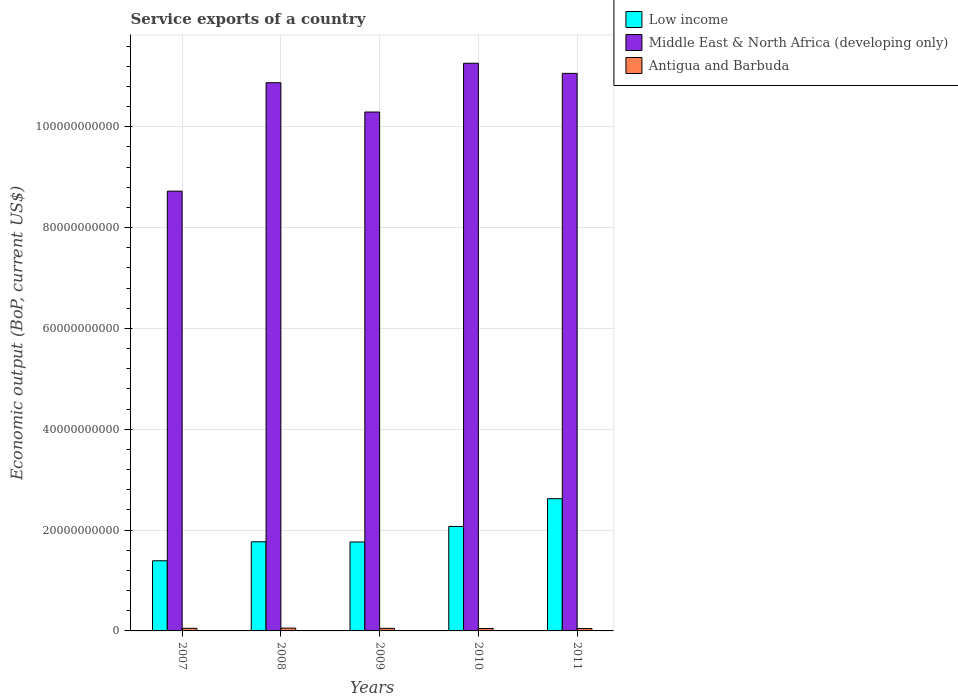How many different coloured bars are there?
Offer a terse response. 3. Are the number of bars on each tick of the X-axis equal?
Your answer should be compact. Yes. How many bars are there on the 1st tick from the left?
Offer a terse response. 3. How many bars are there on the 4th tick from the right?
Keep it short and to the point. 3. What is the label of the 4th group of bars from the left?
Provide a short and direct response. 2010. What is the service exports in Antigua and Barbuda in 2009?
Ensure brevity in your answer.  5.11e+08. Across all years, what is the maximum service exports in Low income?
Keep it short and to the point. 2.62e+1. Across all years, what is the minimum service exports in Middle East & North Africa (developing only)?
Your answer should be compact. 8.72e+1. What is the total service exports in Middle East & North Africa (developing only) in the graph?
Offer a terse response. 5.22e+11. What is the difference between the service exports in Middle East & North Africa (developing only) in 2007 and that in 2010?
Your answer should be very brief. -2.54e+1. What is the difference between the service exports in Middle East & North Africa (developing only) in 2008 and the service exports in Antigua and Barbuda in 2009?
Keep it short and to the point. 1.08e+11. What is the average service exports in Antigua and Barbuda per year?
Provide a succinct answer. 5.11e+08. In the year 2007, what is the difference between the service exports in Middle East & North Africa (developing only) and service exports in Low income?
Offer a terse response. 7.33e+1. What is the ratio of the service exports in Low income in 2007 to that in 2009?
Your answer should be compact. 0.79. Is the difference between the service exports in Middle East & North Africa (developing only) in 2010 and 2011 greater than the difference between the service exports in Low income in 2010 and 2011?
Offer a terse response. Yes. What is the difference between the highest and the second highest service exports in Low income?
Ensure brevity in your answer.  5.50e+09. What is the difference between the highest and the lowest service exports in Antigua and Barbuda?
Offer a terse response. 8.19e+07. In how many years, is the service exports in Antigua and Barbuda greater than the average service exports in Antigua and Barbuda taken over all years?
Your answer should be very brief. 3. Is the sum of the service exports in Antigua and Barbuda in 2008 and 2009 greater than the maximum service exports in Middle East & North Africa (developing only) across all years?
Your answer should be very brief. No. What does the 3rd bar from the left in 2010 represents?
Make the answer very short. Antigua and Barbuda. What does the 2nd bar from the right in 2011 represents?
Your answer should be very brief. Middle East & North Africa (developing only). How many bars are there?
Provide a succinct answer. 15. How many years are there in the graph?
Provide a succinct answer. 5. What is the difference between two consecutive major ticks on the Y-axis?
Offer a very short reply. 2.00e+1. Are the values on the major ticks of Y-axis written in scientific E-notation?
Keep it short and to the point. No. How many legend labels are there?
Ensure brevity in your answer.  3. What is the title of the graph?
Ensure brevity in your answer.  Service exports of a country. Does "Aruba" appear as one of the legend labels in the graph?
Offer a terse response. No. What is the label or title of the X-axis?
Provide a succinct answer. Years. What is the label or title of the Y-axis?
Offer a terse response. Economic output (BoP, current US$). What is the Economic output (BoP, current US$) of Low income in 2007?
Keep it short and to the point. 1.39e+1. What is the Economic output (BoP, current US$) in Middle East & North Africa (developing only) in 2007?
Your response must be concise. 8.72e+1. What is the Economic output (BoP, current US$) of Antigua and Barbuda in 2007?
Give a very brief answer. 5.22e+08. What is the Economic output (BoP, current US$) of Low income in 2008?
Your answer should be compact. 1.77e+1. What is the Economic output (BoP, current US$) of Middle East & North Africa (developing only) in 2008?
Ensure brevity in your answer.  1.09e+11. What is the Economic output (BoP, current US$) in Antigua and Barbuda in 2008?
Your answer should be very brief. 5.60e+08. What is the Economic output (BoP, current US$) in Low income in 2009?
Your answer should be very brief. 1.76e+1. What is the Economic output (BoP, current US$) in Middle East & North Africa (developing only) in 2009?
Provide a succinct answer. 1.03e+11. What is the Economic output (BoP, current US$) in Antigua and Barbuda in 2009?
Keep it short and to the point. 5.11e+08. What is the Economic output (BoP, current US$) of Low income in 2010?
Keep it short and to the point. 2.07e+1. What is the Economic output (BoP, current US$) of Middle East & North Africa (developing only) in 2010?
Your answer should be very brief. 1.13e+11. What is the Economic output (BoP, current US$) in Antigua and Barbuda in 2010?
Offer a very short reply. 4.78e+08. What is the Economic output (BoP, current US$) in Low income in 2011?
Your response must be concise. 2.62e+1. What is the Economic output (BoP, current US$) in Middle East & North Africa (developing only) in 2011?
Your answer should be very brief. 1.11e+11. What is the Economic output (BoP, current US$) of Antigua and Barbuda in 2011?
Give a very brief answer. 4.82e+08. Across all years, what is the maximum Economic output (BoP, current US$) of Low income?
Provide a succinct answer. 2.62e+1. Across all years, what is the maximum Economic output (BoP, current US$) in Middle East & North Africa (developing only)?
Ensure brevity in your answer.  1.13e+11. Across all years, what is the maximum Economic output (BoP, current US$) in Antigua and Barbuda?
Offer a very short reply. 5.60e+08. Across all years, what is the minimum Economic output (BoP, current US$) of Low income?
Provide a succinct answer. 1.39e+1. Across all years, what is the minimum Economic output (BoP, current US$) of Middle East & North Africa (developing only)?
Make the answer very short. 8.72e+1. Across all years, what is the minimum Economic output (BoP, current US$) of Antigua and Barbuda?
Offer a terse response. 4.78e+08. What is the total Economic output (BoP, current US$) of Low income in the graph?
Offer a terse response. 9.62e+1. What is the total Economic output (BoP, current US$) in Middle East & North Africa (developing only) in the graph?
Ensure brevity in your answer.  5.22e+11. What is the total Economic output (BoP, current US$) of Antigua and Barbuda in the graph?
Offer a very short reply. 2.55e+09. What is the difference between the Economic output (BoP, current US$) in Low income in 2007 and that in 2008?
Offer a terse response. -3.77e+09. What is the difference between the Economic output (BoP, current US$) of Middle East & North Africa (developing only) in 2007 and that in 2008?
Your answer should be compact. -2.15e+1. What is the difference between the Economic output (BoP, current US$) in Antigua and Barbuda in 2007 and that in 2008?
Give a very brief answer. -3.80e+07. What is the difference between the Economic output (BoP, current US$) of Low income in 2007 and that in 2009?
Your answer should be very brief. -3.72e+09. What is the difference between the Economic output (BoP, current US$) of Middle East & North Africa (developing only) in 2007 and that in 2009?
Ensure brevity in your answer.  -1.57e+1. What is the difference between the Economic output (BoP, current US$) in Antigua and Barbuda in 2007 and that in 2009?
Offer a terse response. 1.11e+07. What is the difference between the Economic output (BoP, current US$) in Low income in 2007 and that in 2010?
Make the answer very short. -6.81e+09. What is the difference between the Economic output (BoP, current US$) in Middle East & North Africa (developing only) in 2007 and that in 2010?
Your response must be concise. -2.54e+1. What is the difference between the Economic output (BoP, current US$) in Antigua and Barbuda in 2007 and that in 2010?
Provide a succinct answer. 4.39e+07. What is the difference between the Economic output (BoP, current US$) in Low income in 2007 and that in 2011?
Keep it short and to the point. -1.23e+1. What is the difference between the Economic output (BoP, current US$) of Middle East & North Africa (developing only) in 2007 and that in 2011?
Your response must be concise. -2.34e+1. What is the difference between the Economic output (BoP, current US$) in Antigua and Barbuda in 2007 and that in 2011?
Offer a very short reply. 4.04e+07. What is the difference between the Economic output (BoP, current US$) of Low income in 2008 and that in 2009?
Offer a terse response. 4.28e+07. What is the difference between the Economic output (BoP, current US$) in Middle East & North Africa (developing only) in 2008 and that in 2009?
Ensure brevity in your answer.  5.81e+09. What is the difference between the Economic output (BoP, current US$) in Antigua and Barbuda in 2008 and that in 2009?
Ensure brevity in your answer.  4.91e+07. What is the difference between the Economic output (BoP, current US$) in Low income in 2008 and that in 2010?
Make the answer very short. -3.04e+09. What is the difference between the Economic output (BoP, current US$) of Middle East & North Africa (developing only) in 2008 and that in 2010?
Offer a very short reply. -3.86e+09. What is the difference between the Economic output (BoP, current US$) of Antigua and Barbuda in 2008 and that in 2010?
Keep it short and to the point. 8.19e+07. What is the difference between the Economic output (BoP, current US$) of Low income in 2008 and that in 2011?
Ensure brevity in your answer.  -8.54e+09. What is the difference between the Economic output (BoP, current US$) in Middle East & North Africa (developing only) in 2008 and that in 2011?
Make the answer very short. -1.85e+09. What is the difference between the Economic output (BoP, current US$) of Antigua and Barbuda in 2008 and that in 2011?
Your response must be concise. 7.84e+07. What is the difference between the Economic output (BoP, current US$) in Low income in 2009 and that in 2010?
Provide a short and direct response. -3.09e+09. What is the difference between the Economic output (BoP, current US$) of Middle East & North Africa (developing only) in 2009 and that in 2010?
Make the answer very short. -9.67e+09. What is the difference between the Economic output (BoP, current US$) of Antigua and Barbuda in 2009 and that in 2010?
Keep it short and to the point. 3.28e+07. What is the difference between the Economic output (BoP, current US$) of Low income in 2009 and that in 2011?
Ensure brevity in your answer.  -8.59e+09. What is the difference between the Economic output (BoP, current US$) of Middle East & North Africa (developing only) in 2009 and that in 2011?
Your answer should be compact. -7.67e+09. What is the difference between the Economic output (BoP, current US$) in Antigua and Barbuda in 2009 and that in 2011?
Provide a succinct answer. 2.93e+07. What is the difference between the Economic output (BoP, current US$) of Low income in 2010 and that in 2011?
Your response must be concise. -5.50e+09. What is the difference between the Economic output (BoP, current US$) in Middle East & North Africa (developing only) in 2010 and that in 2011?
Keep it short and to the point. 2.01e+09. What is the difference between the Economic output (BoP, current US$) in Antigua and Barbuda in 2010 and that in 2011?
Your answer should be compact. -3.49e+06. What is the difference between the Economic output (BoP, current US$) of Low income in 2007 and the Economic output (BoP, current US$) of Middle East & North Africa (developing only) in 2008?
Provide a succinct answer. -9.48e+1. What is the difference between the Economic output (BoP, current US$) in Low income in 2007 and the Economic output (BoP, current US$) in Antigua and Barbuda in 2008?
Provide a short and direct response. 1.34e+1. What is the difference between the Economic output (BoP, current US$) of Middle East & North Africa (developing only) in 2007 and the Economic output (BoP, current US$) of Antigua and Barbuda in 2008?
Your response must be concise. 8.67e+1. What is the difference between the Economic output (BoP, current US$) in Low income in 2007 and the Economic output (BoP, current US$) in Middle East & North Africa (developing only) in 2009?
Give a very brief answer. -8.90e+1. What is the difference between the Economic output (BoP, current US$) of Low income in 2007 and the Economic output (BoP, current US$) of Antigua and Barbuda in 2009?
Provide a short and direct response. 1.34e+1. What is the difference between the Economic output (BoP, current US$) of Middle East & North Africa (developing only) in 2007 and the Economic output (BoP, current US$) of Antigua and Barbuda in 2009?
Ensure brevity in your answer.  8.67e+1. What is the difference between the Economic output (BoP, current US$) in Low income in 2007 and the Economic output (BoP, current US$) in Middle East & North Africa (developing only) in 2010?
Give a very brief answer. -9.87e+1. What is the difference between the Economic output (BoP, current US$) of Low income in 2007 and the Economic output (BoP, current US$) of Antigua and Barbuda in 2010?
Keep it short and to the point. 1.34e+1. What is the difference between the Economic output (BoP, current US$) of Middle East & North Africa (developing only) in 2007 and the Economic output (BoP, current US$) of Antigua and Barbuda in 2010?
Your response must be concise. 8.67e+1. What is the difference between the Economic output (BoP, current US$) of Low income in 2007 and the Economic output (BoP, current US$) of Middle East & North Africa (developing only) in 2011?
Offer a very short reply. -9.67e+1. What is the difference between the Economic output (BoP, current US$) of Low income in 2007 and the Economic output (BoP, current US$) of Antigua and Barbuda in 2011?
Provide a short and direct response. 1.34e+1. What is the difference between the Economic output (BoP, current US$) of Middle East & North Africa (developing only) in 2007 and the Economic output (BoP, current US$) of Antigua and Barbuda in 2011?
Your answer should be very brief. 8.67e+1. What is the difference between the Economic output (BoP, current US$) of Low income in 2008 and the Economic output (BoP, current US$) of Middle East & North Africa (developing only) in 2009?
Keep it short and to the point. -8.52e+1. What is the difference between the Economic output (BoP, current US$) of Low income in 2008 and the Economic output (BoP, current US$) of Antigua and Barbuda in 2009?
Offer a terse response. 1.72e+1. What is the difference between the Economic output (BoP, current US$) of Middle East & North Africa (developing only) in 2008 and the Economic output (BoP, current US$) of Antigua and Barbuda in 2009?
Offer a very short reply. 1.08e+11. What is the difference between the Economic output (BoP, current US$) of Low income in 2008 and the Economic output (BoP, current US$) of Middle East & North Africa (developing only) in 2010?
Keep it short and to the point. -9.49e+1. What is the difference between the Economic output (BoP, current US$) of Low income in 2008 and the Economic output (BoP, current US$) of Antigua and Barbuda in 2010?
Make the answer very short. 1.72e+1. What is the difference between the Economic output (BoP, current US$) in Middle East & North Africa (developing only) in 2008 and the Economic output (BoP, current US$) in Antigua and Barbuda in 2010?
Keep it short and to the point. 1.08e+11. What is the difference between the Economic output (BoP, current US$) in Low income in 2008 and the Economic output (BoP, current US$) in Middle East & North Africa (developing only) in 2011?
Your answer should be very brief. -9.29e+1. What is the difference between the Economic output (BoP, current US$) of Low income in 2008 and the Economic output (BoP, current US$) of Antigua and Barbuda in 2011?
Provide a short and direct response. 1.72e+1. What is the difference between the Economic output (BoP, current US$) in Middle East & North Africa (developing only) in 2008 and the Economic output (BoP, current US$) in Antigua and Barbuda in 2011?
Make the answer very short. 1.08e+11. What is the difference between the Economic output (BoP, current US$) in Low income in 2009 and the Economic output (BoP, current US$) in Middle East & North Africa (developing only) in 2010?
Offer a very short reply. -9.49e+1. What is the difference between the Economic output (BoP, current US$) of Low income in 2009 and the Economic output (BoP, current US$) of Antigua and Barbuda in 2010?
Make the answer very short. 1.72e+1. What is the difference between the Economic output (BoP, current US$) in Middle East & North Africa (developing only) in 2009 and the Economic output (BoP, current US$) in Antigua and Barbuda in 2010?
Your response must be concise. 1.02e+11. What is the difference between the Economic output (BoP, current US$) of Low income in 2009 and the Economic output (BoP, current US$) of Middle East & North Africa (developing only) in 2011?
Offer a terse response. -9.29e+1. What is the difference between the Economic output (BoP, current US$) of Low income in 2009 and the Economic output (BoP, current US$) of Antigua and Barbuda in 2011?
Your answer should be very brief. 1.72e+1. What is the difference between the Economic output (BoP, current US$) of Middle East & North Africa (developing only) in 2009 and the Economic output (BoP, current US$) of Antigua and Barbuda in 2011?
Your answer should be very brief. 1.02e+11. What is the difference between the Economic output (BoP, current US$) in Low income in 2010 and the Economic output (BoP, current US$) in Middle East & North Africa (developing only) in 2011?
Give a very brief answer. -8.99e+1. What is the difference between the Economic output (BoP, current US$) in Low income in 2010 and the Economic output (BoP, current US$) in Antigua and Barbuda in 2011?
Offer a very short reply. 2.02e+1. What is the difference between the Economic output (BoP, current US$) of Middle East & North Africa (developing only) in 2010 and the Economic output (BoP, current US$) of Antigua and Barbuda in 2011?
Ensure brevity in your answer.  1.12e+11. What is the average Economic output (BoP, current US$) in Low income per year?
Make the answer very short. 1.92e+1. What is the average Economic output (BoP, current US$) of Middle East & North Africa (developing only) per year?
Your answer should be compact. 1.04e+11. What is the average Economic output (BoP, current US$) in Antigua and Barbuda per year?
Your response must be concise. 5.11e+08. In the year 2007, what is the difference between the Economic output (BoP, current US$) of Low income and Economic output (BoP, current US$) of Middle East & North Africa (developing only)?
Give a very brief answer. -7.33e+1. In the year 2007, what is the difference between the Economic output (BoP, current US$) in Low income and Economic output (BoP, current US$) in Antigua and Barbuda?
Offer a terse response. 1.34e+1. In the year 2007, what is the difference between the Economic output (BoP, current US$) in Middle East & North Africa (developing only) and Economic output (BoP, current US$) in Antigua and Barbuda?
Give a very brief answer. 8.67e+1. In the year 2008, what is the difference between the Economic output (BoP, current US$) in Low income and Economic output (BoP, current US$) in Middle East & North Africa (developing only)?
Your response must be concise. -9.10e+1. In the year 2008, what is the difference between the Economic output (BoP, current US$) of Low income and Economic output (BoP, current US$) of Antigua and Barbuda?
Your answer should be very brief. 1.71e+1. In the year 2008, what is the difference between the Economic output (BoP, current US$) of Middle East & North Africa (developing only) and Economic output (BoP, current US$) of Antigua and Barbuda?
Give a very brief answer. 1.08e+11. In the year 2009, what is the difference between the Economic output (BoP, current US$) of Low income and Economic output (BoP, current US$) of Middle East & North Africa (developing only)?
Your answer should be compact. -8.53e+1. In the year 2009, what is the difference between the Economic output (BoP, current US$) in Low income and Economic output (BoP, current US$) in Antigua and Barbuda?
Offer a terse response. 1.71e+1. In the year 2009, what is the difference between the Economic output (BoP, current US$) in Middle East & North Africa (developing only) and Economic output (BoP, current US$) in Antigua and Barbuda?
Your response must be concise. 1.02e+11. In the year 2010, what is the difference between the Economic output (BoP, current US$) of Low income and Economic output (BoP, current US$) of Middle East & North Africa (developing only)?
Keep it short and to the point. -9.19e+1. In the year 2010, what is the difference between the Economic output (BoP, current US$) of Low income and Economic output (BoP, current US$) of Antigua and Barbuda?
Make the answer very short. 2.02e+1. In the year 2010, what is the difference between the Economic output (BoP, current US$) in Middle East & North Africa (developing only) and Economic output (BoP, current US$) in Antigua and Barbuda?
Make the answer very short. 1.12e+11. In the year 2011, what is the difference between the Economic output (BoP, current US$) in Low income and Economic output (BoP, current US$) in Middle East & North Africa (developing only)?
Provide a short and direct response. -8.44e+1. In the year 2011, what is the difference between the Economic output (BoP, current US$) of Low income and Economic output (BoP, current US$) of Antigua and Barbuda?
Ensure brevity in your answer.  2.57e+1. In the year 2011, what is the difference between the Economic output (BoP, current US$) of Middle East & North Africa (developing only) and Economic output (BoP, current US$) of Antigua and Barbuda?
Ensure brevity in your answer.  1.10e+11. What is the ratio of the Economic output (BoP, current US$) in Low income in 2007 to that in 2008?
Your response must be concise. 0.79. What is the ratio of the Economic output (BoP, current US$) of Middle East & North Africa (developing only) in 2007 to that in 2008?
Provide a succinct answer. 0.8. What is the ratio of the Economic output (BoP, current US$) in Antigua and Barbuda in 2007 to that in 2008?
Ensure brevity in your answer.  0.93. What is the ratio of the Economic output (BoP, current US$) in Low income in 2007 to that in 2009?
Your answer should be very brief. 0.79. What is the ratio of the Economic output (BoP, current US$) in Middle East & North Africa (developing only) in 2007 to that in 2009?
Your answer should be very brief. 0.85. What is the ratio of the Economic output (BoP, current US$) of Antigua and Barbuda in 2007 to that in 2009?
Your answer should be very brief. 1.02. What is the ratio of the Economic output (BoP, current US$) of Low income in 2007 to that in 2010?
Your answer should be very brief. 0.67. What is the ratio of the Economic output (BoP, current US$) in Middle East & North Africa (developing only) in 2007 to that in 2010?
Provide a short and direct response. 0.77. What is the ratio of the Economic output (BoP, current US$) of Antigua and Barbuda in 2007 to that in 2010?
Your answer should be very brief. 1.09. What is the ratio of the Economic output (BoP, current US$) in Low income in 2007 to that in 2011?
Keep it short and to the point. 0.53. What is the ratio of the Economic output (BoP, current US$) of Middle East & North Africa (developing only) in 2007 to that in 2011?
Give a very brief answer. 0.79. What is the ratio of the Economic output (BoP, current US$) of Antigua and Barbuda in 2007 to that in 2011?
Make the answer very short. 1.08. What is the ratio of the Economic output (BoP, current US$) in Low income in 2008 to that in 2009?
Provide a short and direct response. 1. What is the ratio of the Economic output (BoP, current US$) in Middle East & North Africa (developing only) in 2008 to that in 2009?
Your answer should be very brief. 1.06. What is the ratio of the Economic output (BoP, current US$) in Antigua and Barbuda in 2008 to that in 2009?
Make the answer very short. 1.1. What is the ratio of the Economic output (BoP, current US$) in Low income in 2008 to that in 2010?
Provide a succinct answer. 0.85. What is the ratio of the Economic output (BoP, current US$) of Middle East & North Africa (developing only) in 2008 to that in 2010?
Keep it short and to the point. 0.97. What is the ratio of the Economic output (BoP, current US$) of Antigua and Barbuda in 2008 to that in 2010?
Your response must be concise. 1.17. What is the ratio of the Economic output (BoP, current US$) of Low income in 2008 to that in 2011?
Offer a very short reply. 0.67. What is the ratio of the Economic output (BoP, current US$) of Middle East & North Africa (developing only) in 2008 to that in 2011?
Keep it short and to the point. 0.98. What is the ratio of the Economic output (BoP, current US$) of Antigua and Barbuda in 2008 to that in 2011?
Keep it short and to the point. 1.16. What is the ratio of the Economic output (BoP, current US$) of Low income in 2009 to that in 2010?
Your response must be concise. 0.85. What is the ratio of the Economic output (BoP, current US$) of Middle East & North Africa (developing only) in 2009 to that in 2010?
Ensure brevity in your answer.  0.91. What is the ratio of the Economic output (BoP, current US$) of Antigua and Barbuda in 2009 to that in 2010?
Provide a succinct answer. 1.07. What is the ratio of the Economic output (BoP, current US$) of Low income in 2009 to that in 2011?
Make the answer very short. 0.67. What is the ratio of the Economic output (BoP, current US$) of Middle East & North Africa (developing only) in 2009 to that in 2011?
Offer a terse response. 0.93. What is the ratio of the Economic output (BoP, current US$) of Antigua and Barbuda in 2009 to that in 2011?
Give a very brief answer. 1.06. What is the ratio of the Economic output (BoP, current US$) in Low income in 2010 to that in 2011?
Your answer should be compact. 0.79. What is the ratio of the Economic output (BoP, current US$) of Middle East & North Africa (developing only) in 2010 to that in 2011?
Offer a terse response. 1.02. What is the difference between the highest and the second highest Economic output (BoP, current US$) of Low income?
Ensure brevity in your answer.  5.50e+09. What is the difference between the highest and the second highest Economic output (BoP, current US$) in Middle East & North Africa (developing only)?
Keep it short and to the point. 2.01e+09. What is the difference between the highest and the second highest Economic output (BoP, current US$) in Antigua and Barbuda?
Ensure brevity in your answer.  3.80e+07. What is the difference between the highest and the lowest Economic output (BoP, current US$) in Low income?
Provide a succinct answer. 1.23e+1. What is the difference between the highest and the lowest Economic output (BoP, current US$) of Middle East & North Africa (developing only)?
Make the answer very short. 2.54e+1. What is the difference between the highest and the lowest Economic output (BoP, current US$) in Antigua and Barbuda?
Offer a terse response. 8.19e+07. 